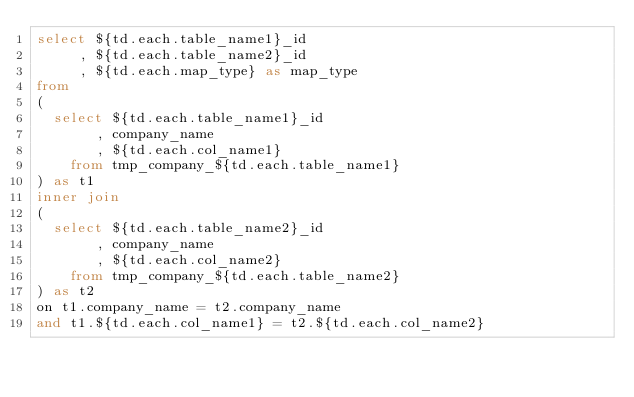<code> <loc_0><loc_0><loc_500><loc_500><_SQL_>select ${td.each.table_name1}_id
     , ${td.each.table_name2}_id
     , ${td.each.map_type} as map_type
from
( 
  select ${td.each.table_name1}_id
       , company_name
       , ${td.each.col_name1}
    from tmp_company_${td.each.table_name1}
) as t1
inner join 
(
  select ${td.each.table_name2}_id
       , company_name
       , ${td.each.col_name2}
    from tmp_company_${td.each.table_name2}
) as t2
on t1.company_name = t2.company_name
and t1.${td.each.col_name1} = t2.${td.each.col_name2}
</code> 